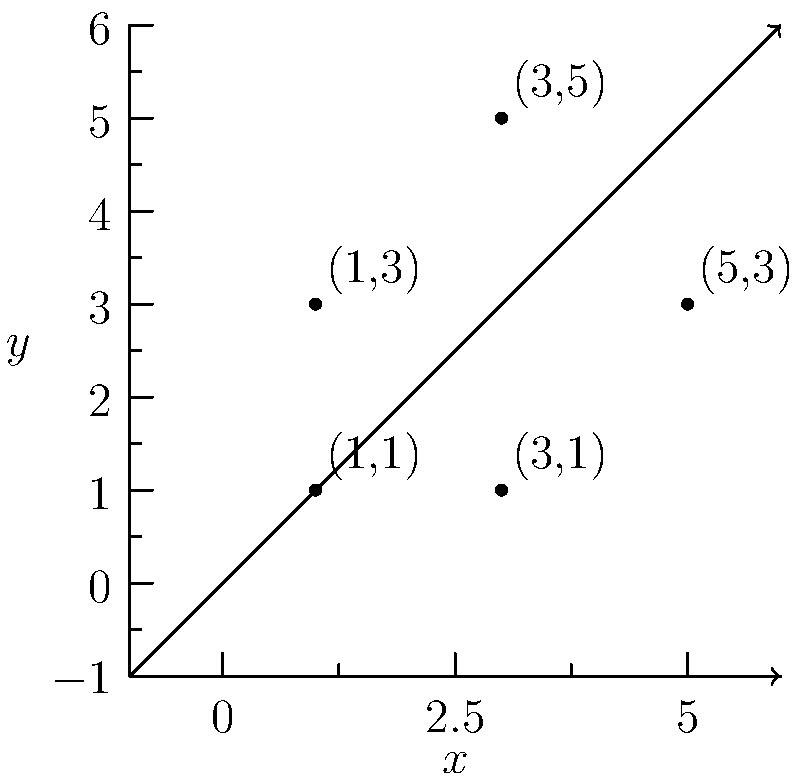In our classroom, we're learning about shapes and coordinates. Let's play a connect-the-dots game! Plot the following points on the coordinate plane and connect them in order: $(1,1)$, $(3,1)$, $(5,3)$, $(3,5)$, and $(1,3)$. What simple shape do we create? Let's follow these steps to solve our shape puzzle:

1. Plot each point on the coordinate plane:
   - $(1,1)$: 1 unit right, 1 unit up
   - $(3,1)$: 3 units right, 1 unit up
   - $(5,3)$: 5 units right, 3 units up
   - $(3,5)$: 3 units right, 5 units up
   - $(1,3)$: 1 unit right, 3 units up

2. Connect the points in the given order:
   - Draw a line from $(1,1)$ to $(3,1)$
   - Then from $(3,1)$ to $(5,3)$
   - Continue to $(3,5)$
   - Then to $(1,3)$
   - Finally, close the shape by connecting back to $(1,1)$

3. Observe the resulting shape:
   - It has 5 sides
   - All sides are straight lines
   - The shape is closed

4. Identify the shape:
   - A closed shape with 5 straight sides is called a pentagon

Therefore, by connecting these points, we've created a pentagon!
Answer: Pentagon 